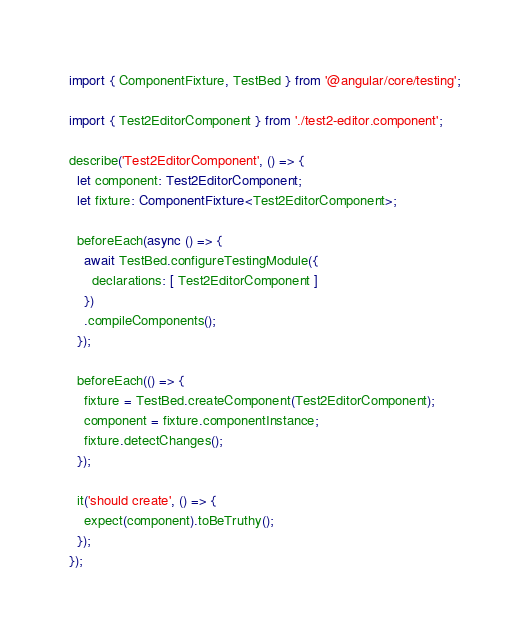Convert code to text. <code><loc_0><loc_0><loc_500><loc_500><_TypeScript_>import { ComponentFixture, TestBed } from '@angular/core/testing';

import { Test2EditorComponent } from './test2-editor.component';

describe('Test2EditorComponent', () => {
  let component: Test2EditorComponent;
  let fixture: ComponentFixture<Test2EditorComponent>;

  beforeEach(async () => {
    await TestBed.configureTestingModule({
      declarations: [ Test2EditorComponent ]
    })
    .compileComponents();
  });

  beforeEach(() => {
    fixture = TestBed.createComponent(Test2EditorComponent);
    component = fixture.componentInstance;
    fixture.detectChanges();
  });

  it('should create', () => {
    expect(component).toBeTruthy();
  });
});
</code> 